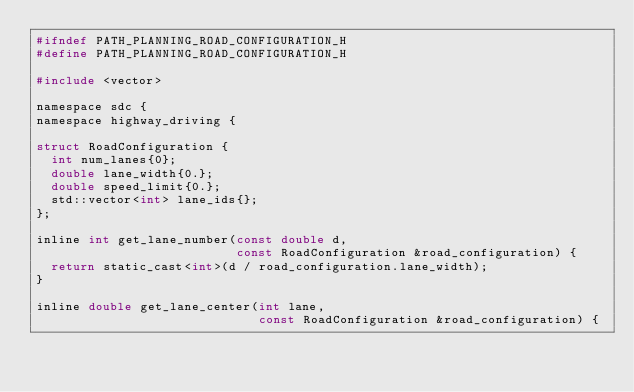<code> <loc_0><loc_0><loc_500><loc_500><_C_>#ifndef PATH_PLANNING_ROAD_CONFIGURATION_H
#define PATH_PLANNING_ROAD_CONFIGURATION_H

#include <vector>

namespace sdc {
namespace highway_driving {

struct RoadConfiguration {
  int num_lanes{0};
  double lane_width{0.};
  double speed_limit{0.};
  std::vector<int> lane_ids{};
};

inline int get_lane_number(const double d,
                           const RoadConfiguration &road_configuration) {
  return static_cast<int>(d / road_configuration.lane_width);
}

inline double get_lane_center(int lane,
                              const RoadConfiguration &road_configuration) {</code> 